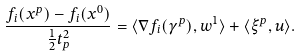Convert formula to latex. <formula><loc_0><loc_0><loc_500><loc_500>\frac { f _ { i } ( x ^ { p } ) - f _ { i } ( x ^ { 0 } ) } { \frac { 1 } { 2 } t ^ { 2 } _ { p } } = \langle \nabla f _ { i } ( \gamma ^ { p } ) , w ^ { 1 } \rangle + \langle \xi ^ { p } , u \rangle .</formula> 